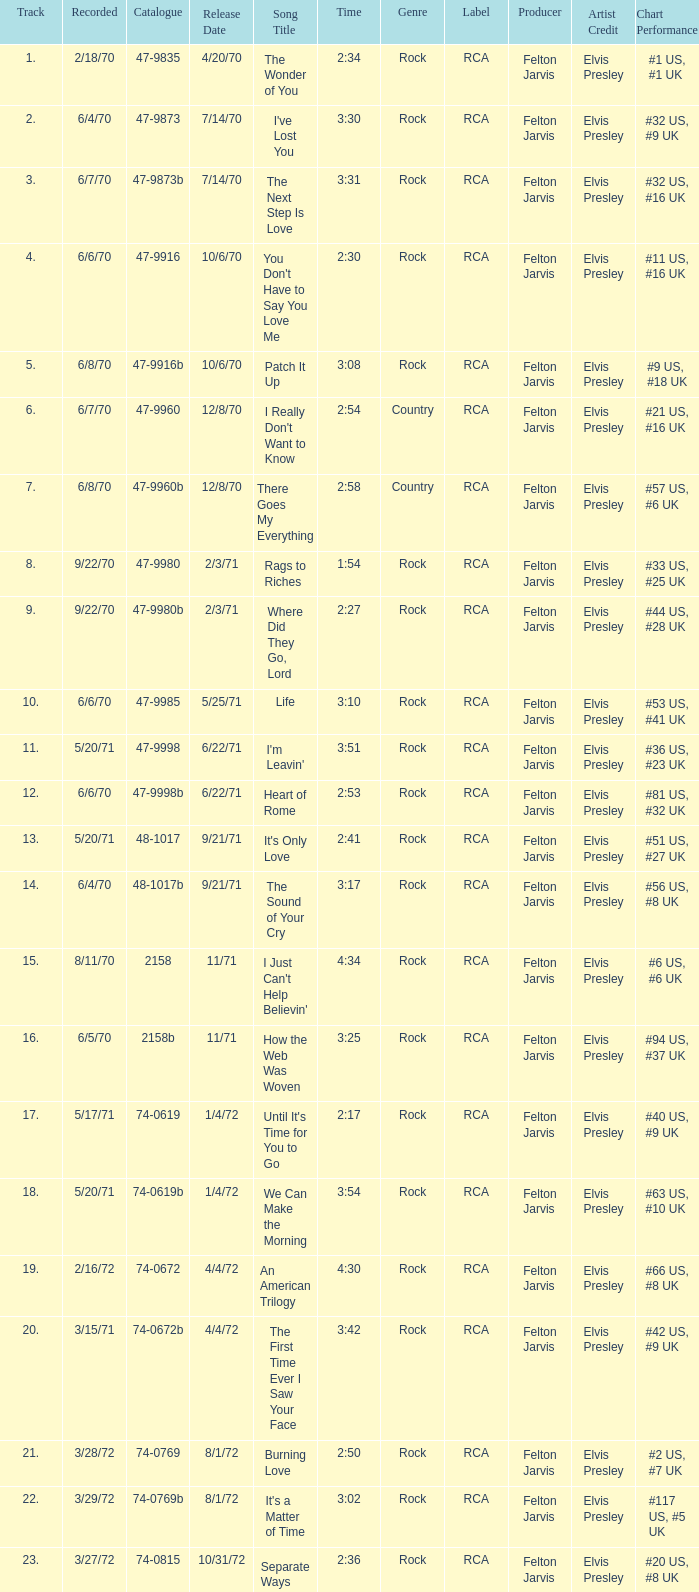What is the highest track for Burning Love? 21.0. 